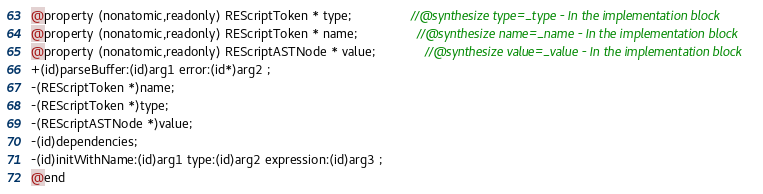<code> <loc_0><loc_0><loc_500><loc_500><_C_>
@property (nonatomic,readonly) REScriptToken * type;                 //@synthesize type=_type - In the implementation block
@property (nonatomic,readonly) REScriptToken * name;                 //@synthesize name=_name - In the implementation block
@property (nonatomic,readonly) REScriptASTNode * value;              //@synthesize value=_value - In the implementation block
+(id)parseBuffer:(id)arg1 error:(id*)arg2 ;
-(REScriptToken *)name;
-(REScriptToken *)type;
-(REScriptASTNode *)value;
-(id)dependencies;
-(id)initWithName:(id)arg1 type:(id)arg2 expression:(id)arg3 ;
@end

</code> 